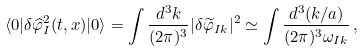<formula> <loc_0><loc_0><loc_500><loc_500>\langle 0 | \delta \widehat { \varphi } _ { I } ^ { 2 } ( t , { x } ) | 0 \rangle = \int \frac { d ^ { 3 } { k } } { ( 2 \pi ) ^ { 3 } } | \delta \widetilde { \varphi } _ { I { k } } | ^ { 2 } \simeq \int \frac { d ^ { 3 } ( { k } / a ) } { ( 2 \pi ) ^ { 3 } \omega _ { I k } } \, ,</formula> 